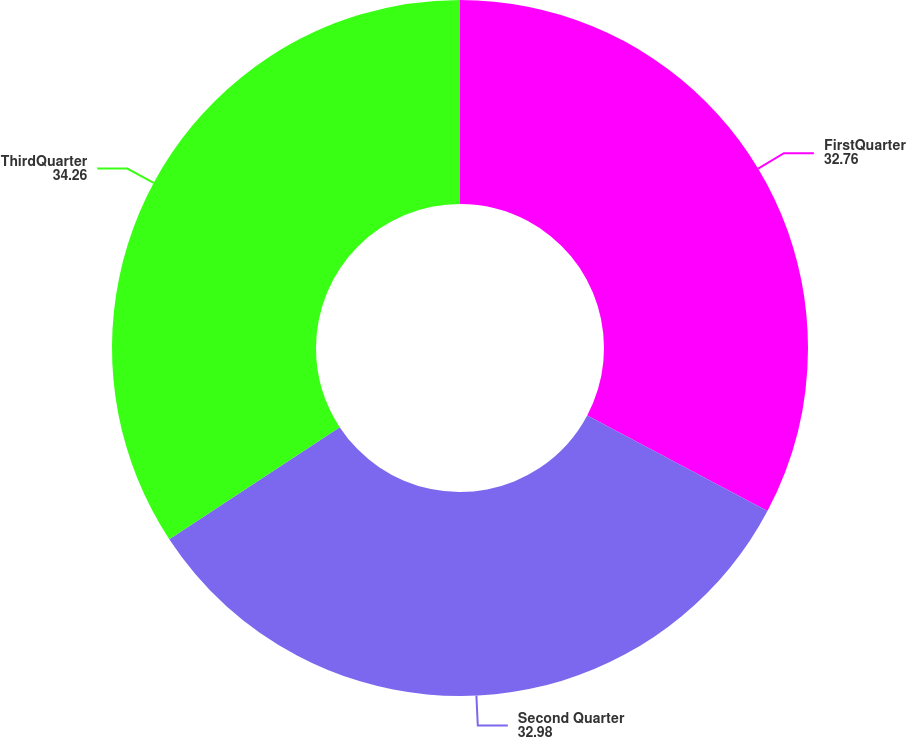<chart> <loc_0><loc_0><loc_500><loc_500><pie_chart><fcel>FirstQuarter<fcel>Second Quarter<fcel>ThirdQuarter<nl><fcel>32.76%<fcel>32.98%<fcel>34.26%<nl></chart> 